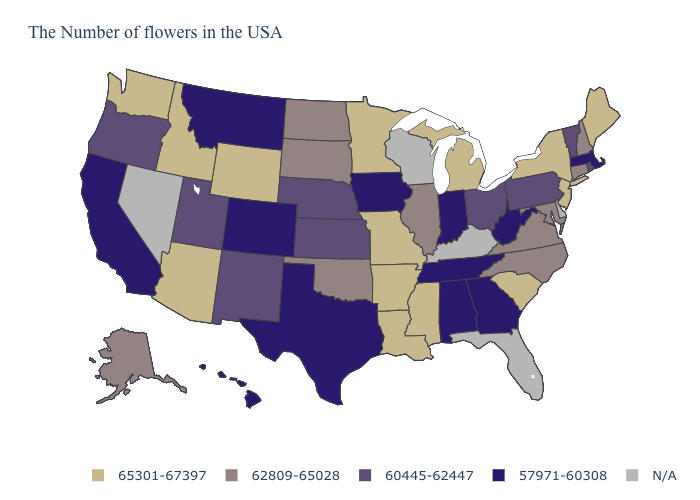What is the value of Utah?
Quick response, please. 60445-62447. What is the value of Illinois?
Keep it brief. 62809-65028. What is the value of Missouri?
Keep it brief. 65301-67397. Name the states that have a value in the range 62809-65028?
Keep it brief. New Hampshire, Connecticut, Maryland, Virginia, North Carolina, Illinois, Oklahoma, South Dakota, North Dakota, Alaska. How many symbols are there in the legend?
Concise answer only. 5. What is the value of Oklahoma?
Keep it brief. 62809-65028. What is the lowest value in the West?
Concise answer only. 57971-60308. Does Georgia have the highest value in the South?
Be succinct. No. Which states have the lowest value in the Northeast?
Keep it brief. Massachusetts. What is the value of Kansas?
Quick response, please. 60445-62447. What is the lowest value in the West?
Quick response, please. 57971-60308. How many symbols are there in the legend?
Give a very brief answer. 5. Among the states that border Kentucky , does Tennessee have the highest value?
Quick response, please. No. Which states hav the highest value in the West?
Concise answer only. Wyoming, Arizona, Idaho, Washington. 